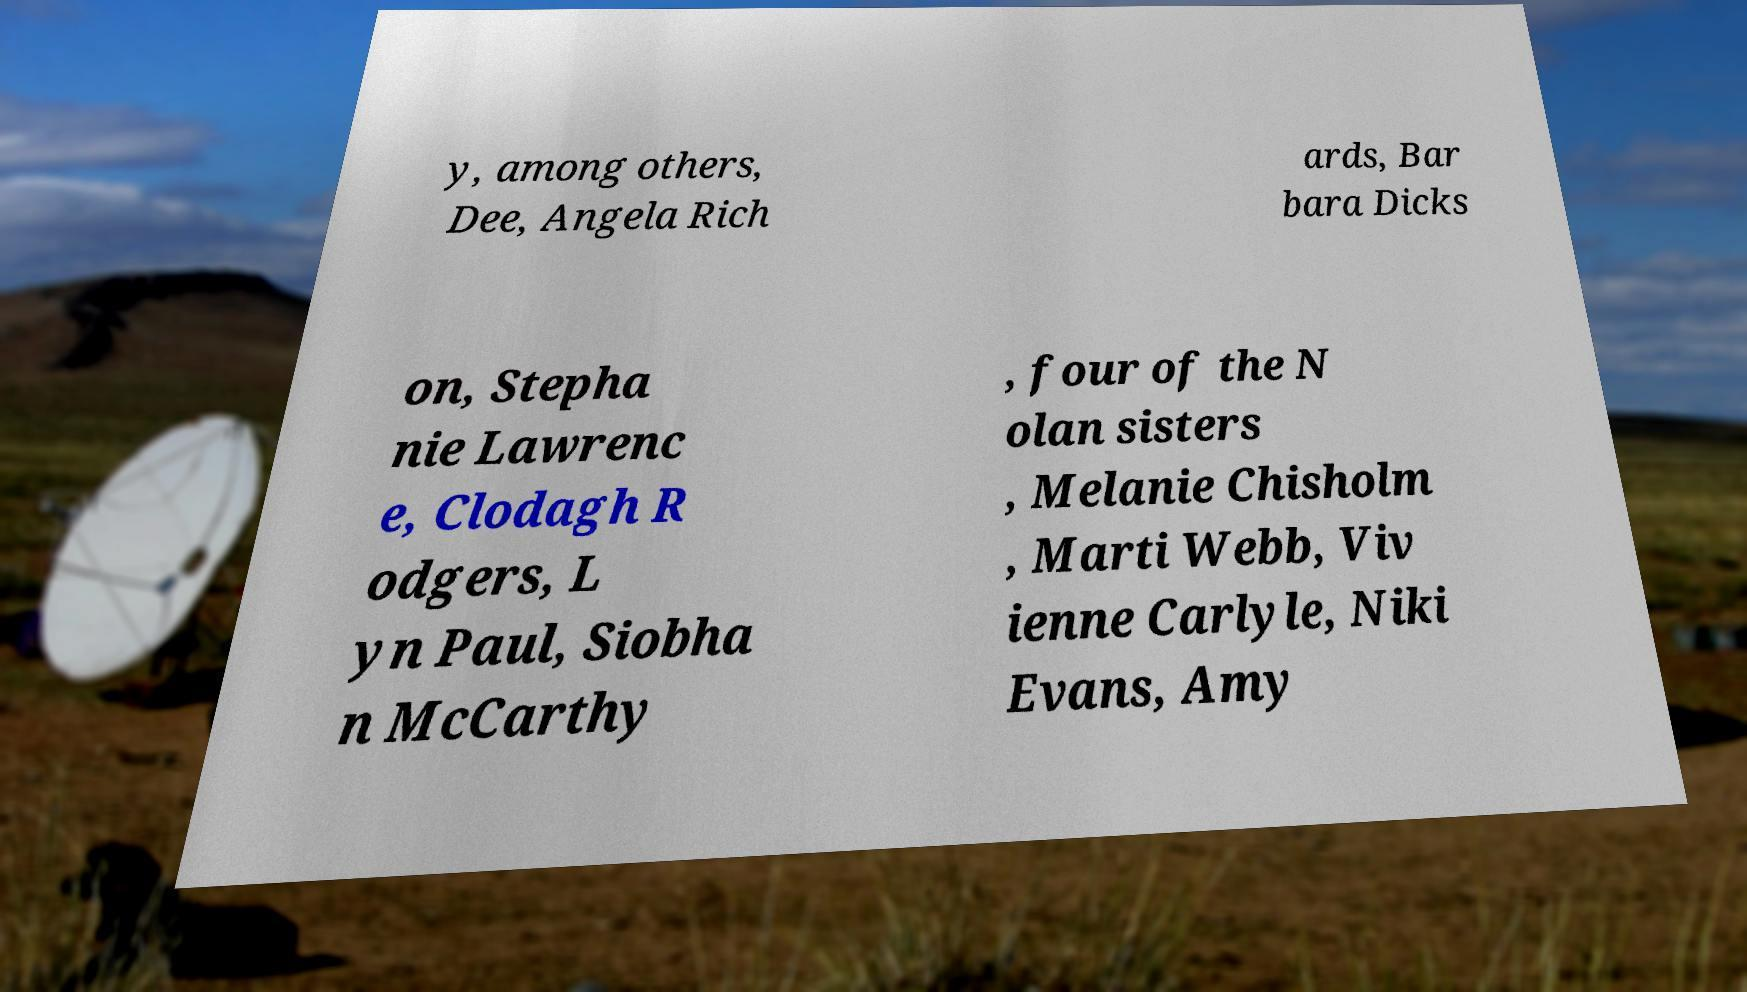Please identify and transcribe the text found in this image. y, among others, Dee, Angela Rich ards, Bar bara Dicks on, Stepha nie Lawrenc e, Clodagh R odgers, L yn Paul, Siobha n McCarthy , four of the N olan sisters , Melanie Chisholm , Marti Webb, Viv ienne Carlyle, Niki Evans, Amy 